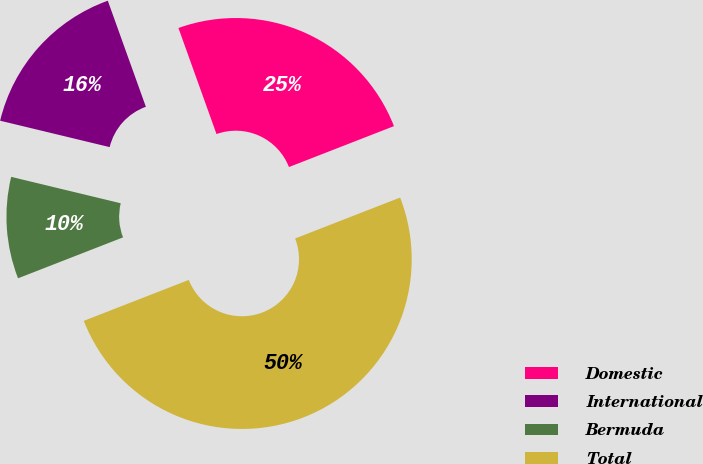<chart> <loc_0><loc_0><loc_500><loc_500><pie_chart><fcel>Domestic<fcel>International<fcel>Bermuda<fcel>Total<nl><fcel>24.57%<fcel>15.75%<fcel>9.68%<fcel>50.0%<nl></chart> 